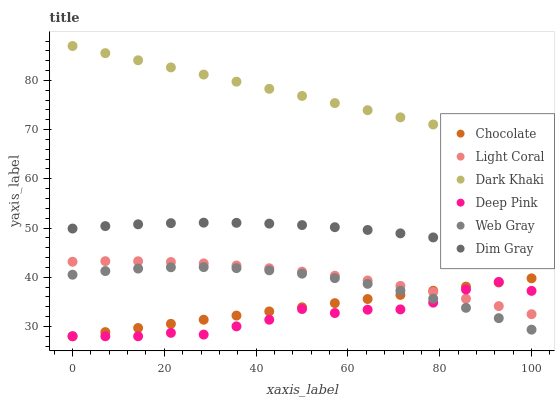Does Deep Pink have the minimum area under the curve?
Answer yes or no. Yes. Does Dark Khaki have the maximum area under the curve?
Answer yes or no. Yes. Does Dim Gray have the minimum area under the curve?
Answer yes or no. No. Does Dim Gray have the maximum area under the curve?
Answer yes or no. No. Is Chocolate the smoothest?
Answer yes or no. Yes. Is Deep Pink the roughest?
Answer yes or no. Yes. Is Dim Gray the smoothest?
Answer yes or no. No. Is Dim Gray the roughest?
Answer yes or no. No. Does Chocolate have the lowest value?
Answer yes or no. Yes. Does Dim Gray have the lowest value?
Answer yes or no. No. Does Dark Khaki have the highest value?
Answer yes or no. Yes. Does Dim Gray have the highest value?
Answer yes or no. No. Is Light Coral less than Dark Khaki?
Answer yes or no. Yes. Is Light Coral greater than Web Gray?
Answer yes or no. Yes. Does Light Coral intersect Deep Pink?
Answer yes or no. Yes. Is Light Coral less than Deep Pink?
Answer yes or no. No. Is Light Coral greater than Deep Pink?
Answer yes or no. No. Does Light Coral intersect Dark Khaki?
Answer yes or no. No. 